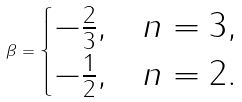<formula> <loc_0><loc_0><loc_500><loc_500>\beta = \begin{cases} - \frac { 2 } { 3 } , & n = 3 , \\ - \frac { 1 } { 2 } , & n = 2 . \end{cases}</formula> 